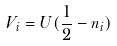Convert formula to latex. <formula><loc_0><loc_0><loc_500><loc_500>V _ { i } = U ( \frac { 1 } { 2 } - n _ { i } ) \,</formula> 